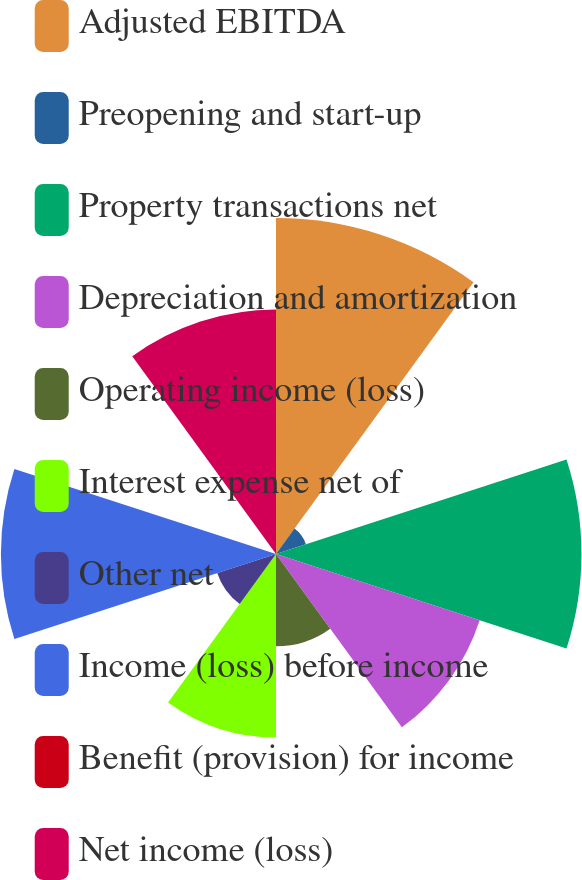Convert chart. <chart><loc_0><loc_0><loc_500><loc_500><pie_chart><fcel>Adjusted EBITDA<fcel>Preopening and start-up<fcel>Property transactions net<fcel>Depreciation and amortization<fcel>Operating income (loss)<fcel>Interest expense net of<fcel>Other net<fcel>Income (loss) before income<fcel>Benefit (provision) for income<fcel>Net income (loss)<nl><fcel>19.25%<fcel>1.8%<fcel>17.5%<fcel>12.27%<fcel>5.29%<fcel>10.52%<fcel>3.54%<fcel>15.76%<fcel>0.05%<fcel>14.01%<nl></chart> 